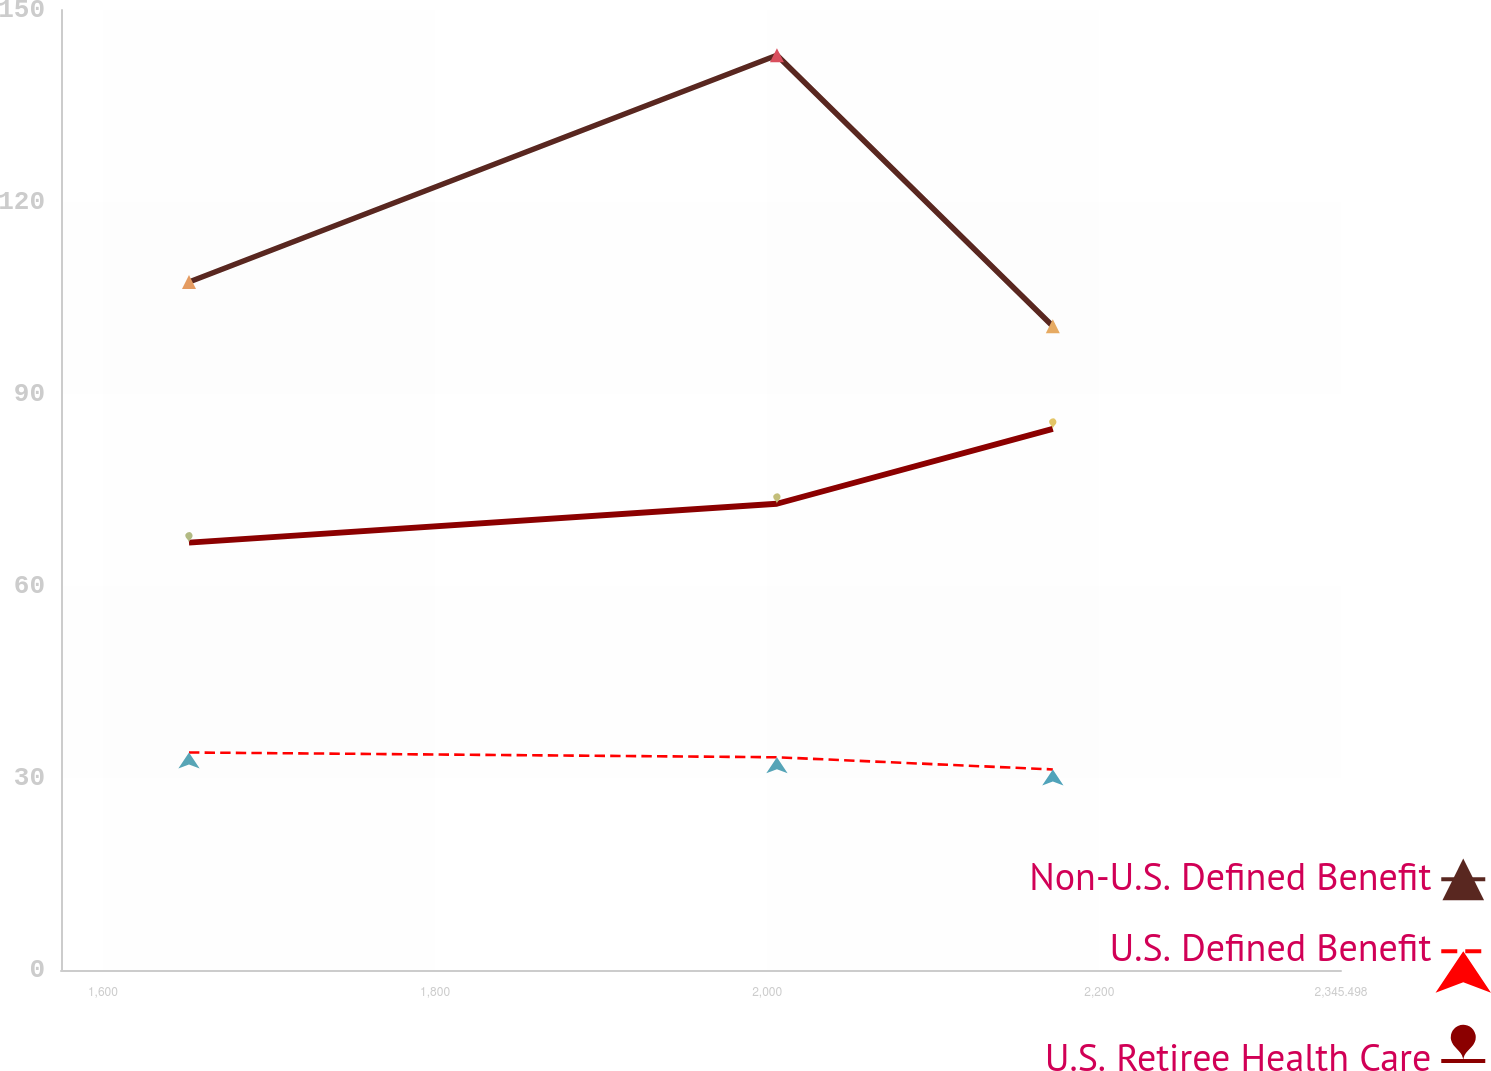Convert chart. <chart><loc_0><loc_0><loc_500><loc_500><line_chart><ecel><fcel>Non-U.S. Defined Benefit<fcel>U.S. Defined Benefit<fcel>U.S. Retiree Health Care<nl><fcel>1651.85<fcel>107.5<fcel>33.99<fcel>66.78<nl><fcel>2005.86<fcel>142.93<fcel>33.24<fcel>72.85<nl><fcel>2171.99<fcel>100.57<fcel>31.34<fcel>84.55<nl><fcel>2346.88<fcel>80.51<fcel>38.81<fcel>97.99<nl><fcel>2422.57<fcel>116.86<fcel>35.83<fcel>94.98<nl></chart> 